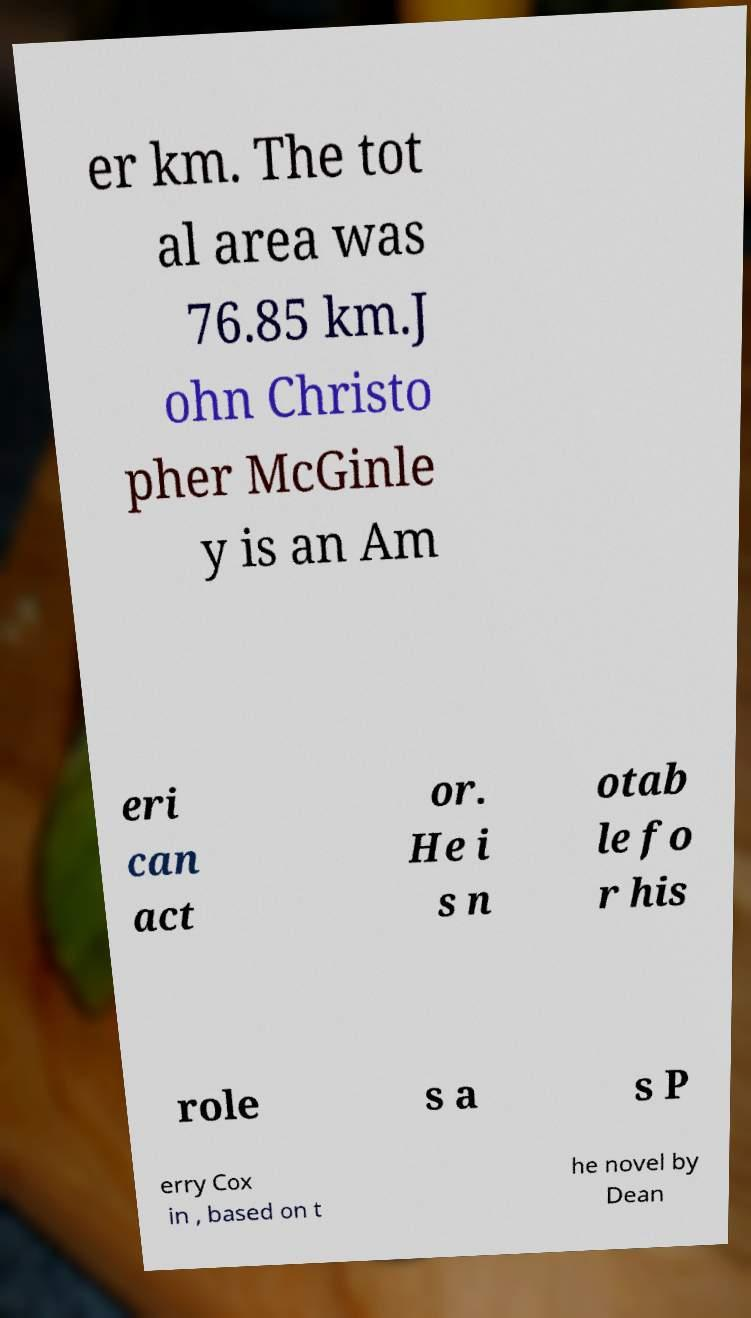Please read and relay the text visible in this image. What does it say? er km. The tot al area was 76.85 km.J ohn Christo pher McGinle y is an Am eri can act or. He i s n otab le fo r his role s a s P erry Cox in , based on t he novel by Dean 